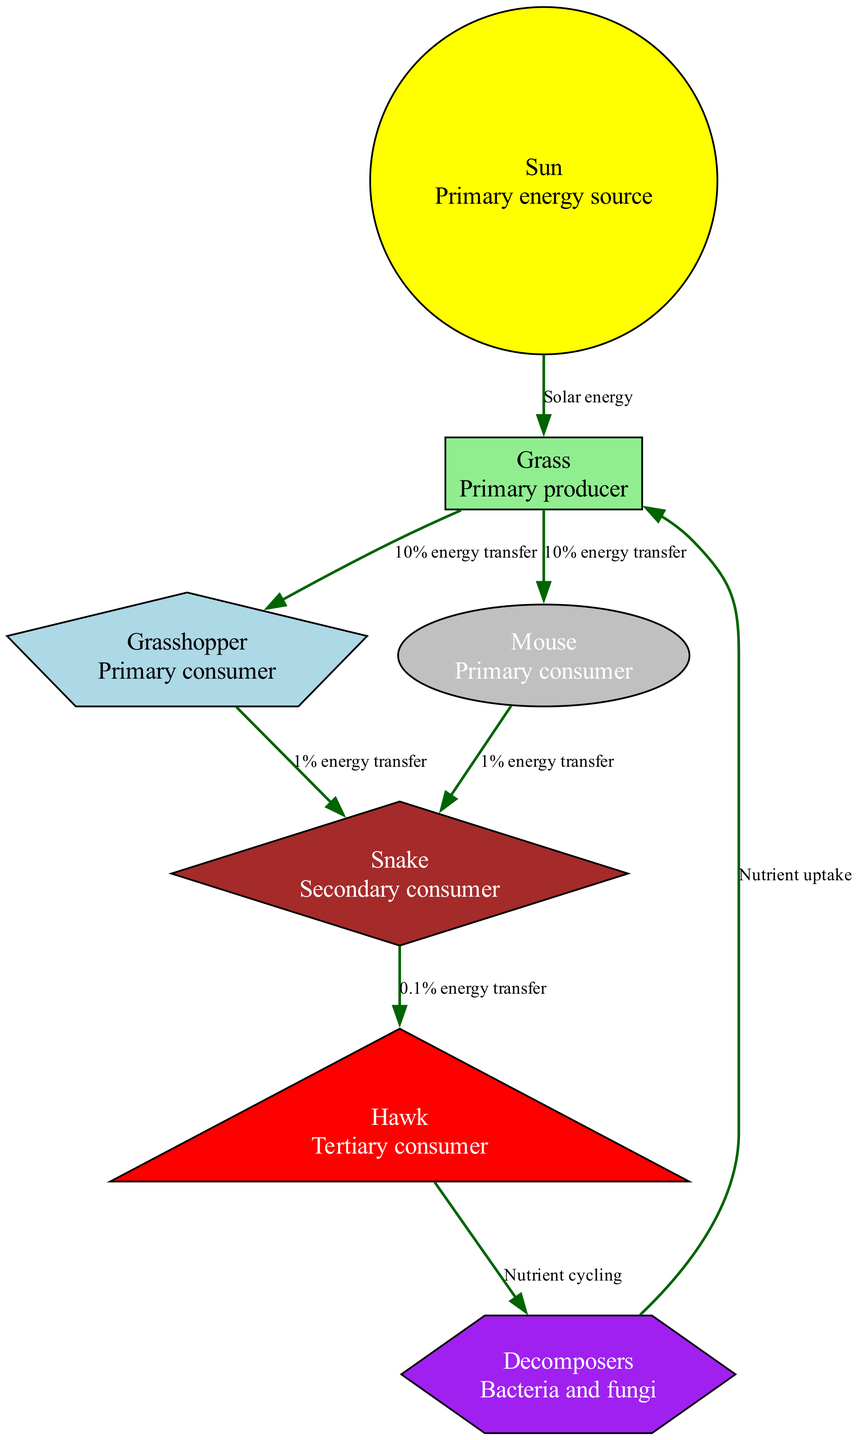What is the primary energy source in the diagram? The diagram indicates that the Sun is the primary energy source as it is the first node listed, and no other node provides energy to others.
Answer: Sun How many nodes are present in the food chain? By counting the nodes listed in the data, there are seven different nodes that represent various levels in the food chain.
Answer: 7 What type of consumer is a Snake? The diagram defines the Snake as a Secondary consumer, which can be identified in the description associated with its node.
Answer: Secondary consumer What percentage of energy is transferred from Grass to Grasshopper? The edge connecting Grass to Grasshopper specifies a 10% energy transfer, which can be directly read from the label on the edge in the diagram.
Answer: 10% Which organism is at the top of the food chain? The highest node in the hierarchy of the food chain is the Hawk, indicating that it occupies the top position among all the listed organisms.
Answer: Hawk What role do Decomposers play in nutrient cycling? The diagram notes that Decomposers contribute to Nutrient cycling, reflected in the label connecting the Decomposers to the Hawk node.
Answer: Nutrient cycling How much energy is transferred from the Grasshopper to the Snake? The edge between Grasshopper and Snake shows a 1% energy transfer, which can be found directly on the connecting edge in the diagram.
Answer: 1% Which trophic level does the Mouse belong to? The Mouse is identified as a Primary consumer, which can be confirmed by its placement and description within the diagram.
Answer: Primary consumer What feedback loop exists between Decomposers and Grass? The diagram indicates that Decomposers facilitate Nutrient uptake for Grass, creating a cyclical relationship between these two elements.
Answer: Nutrient uptake 